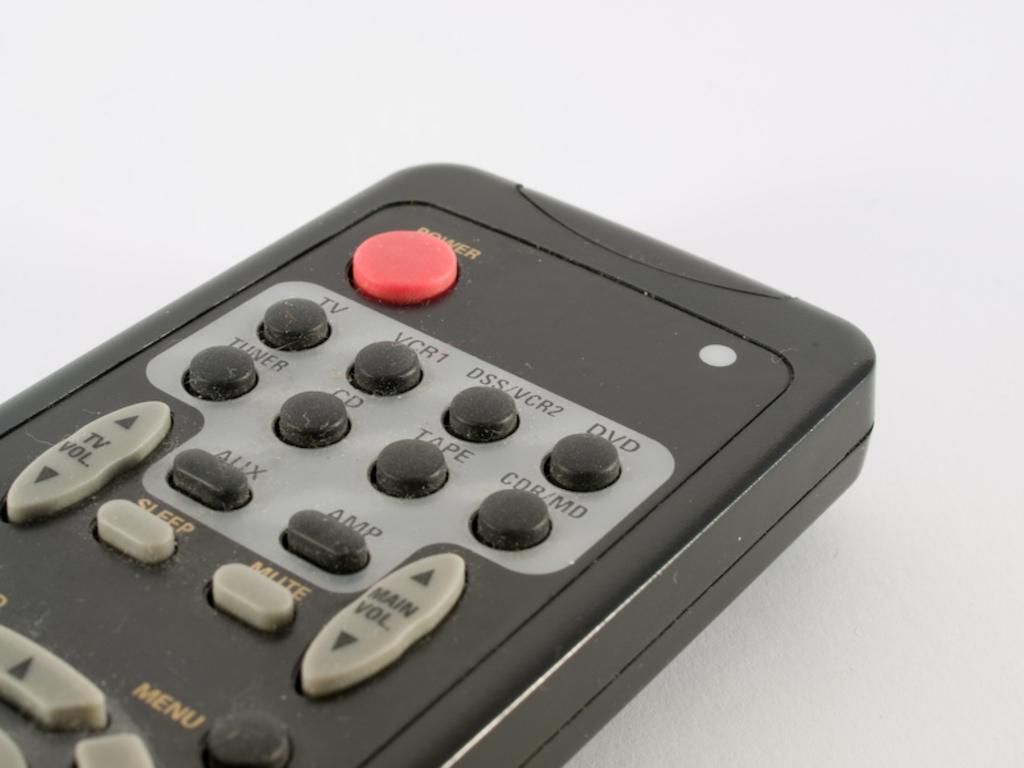What button is the red one?
Give a very brief answer. Power. 